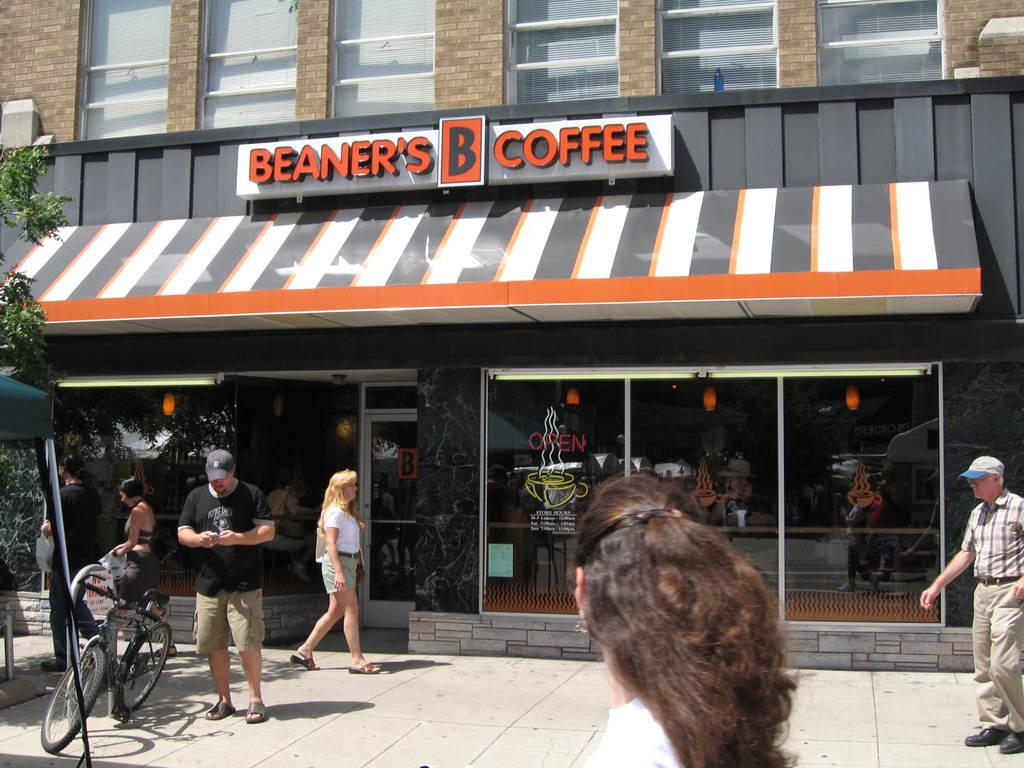<image>
Present a compact description of the photo's key features. Beaners coffer shop seems to be a popular shop for locals. 